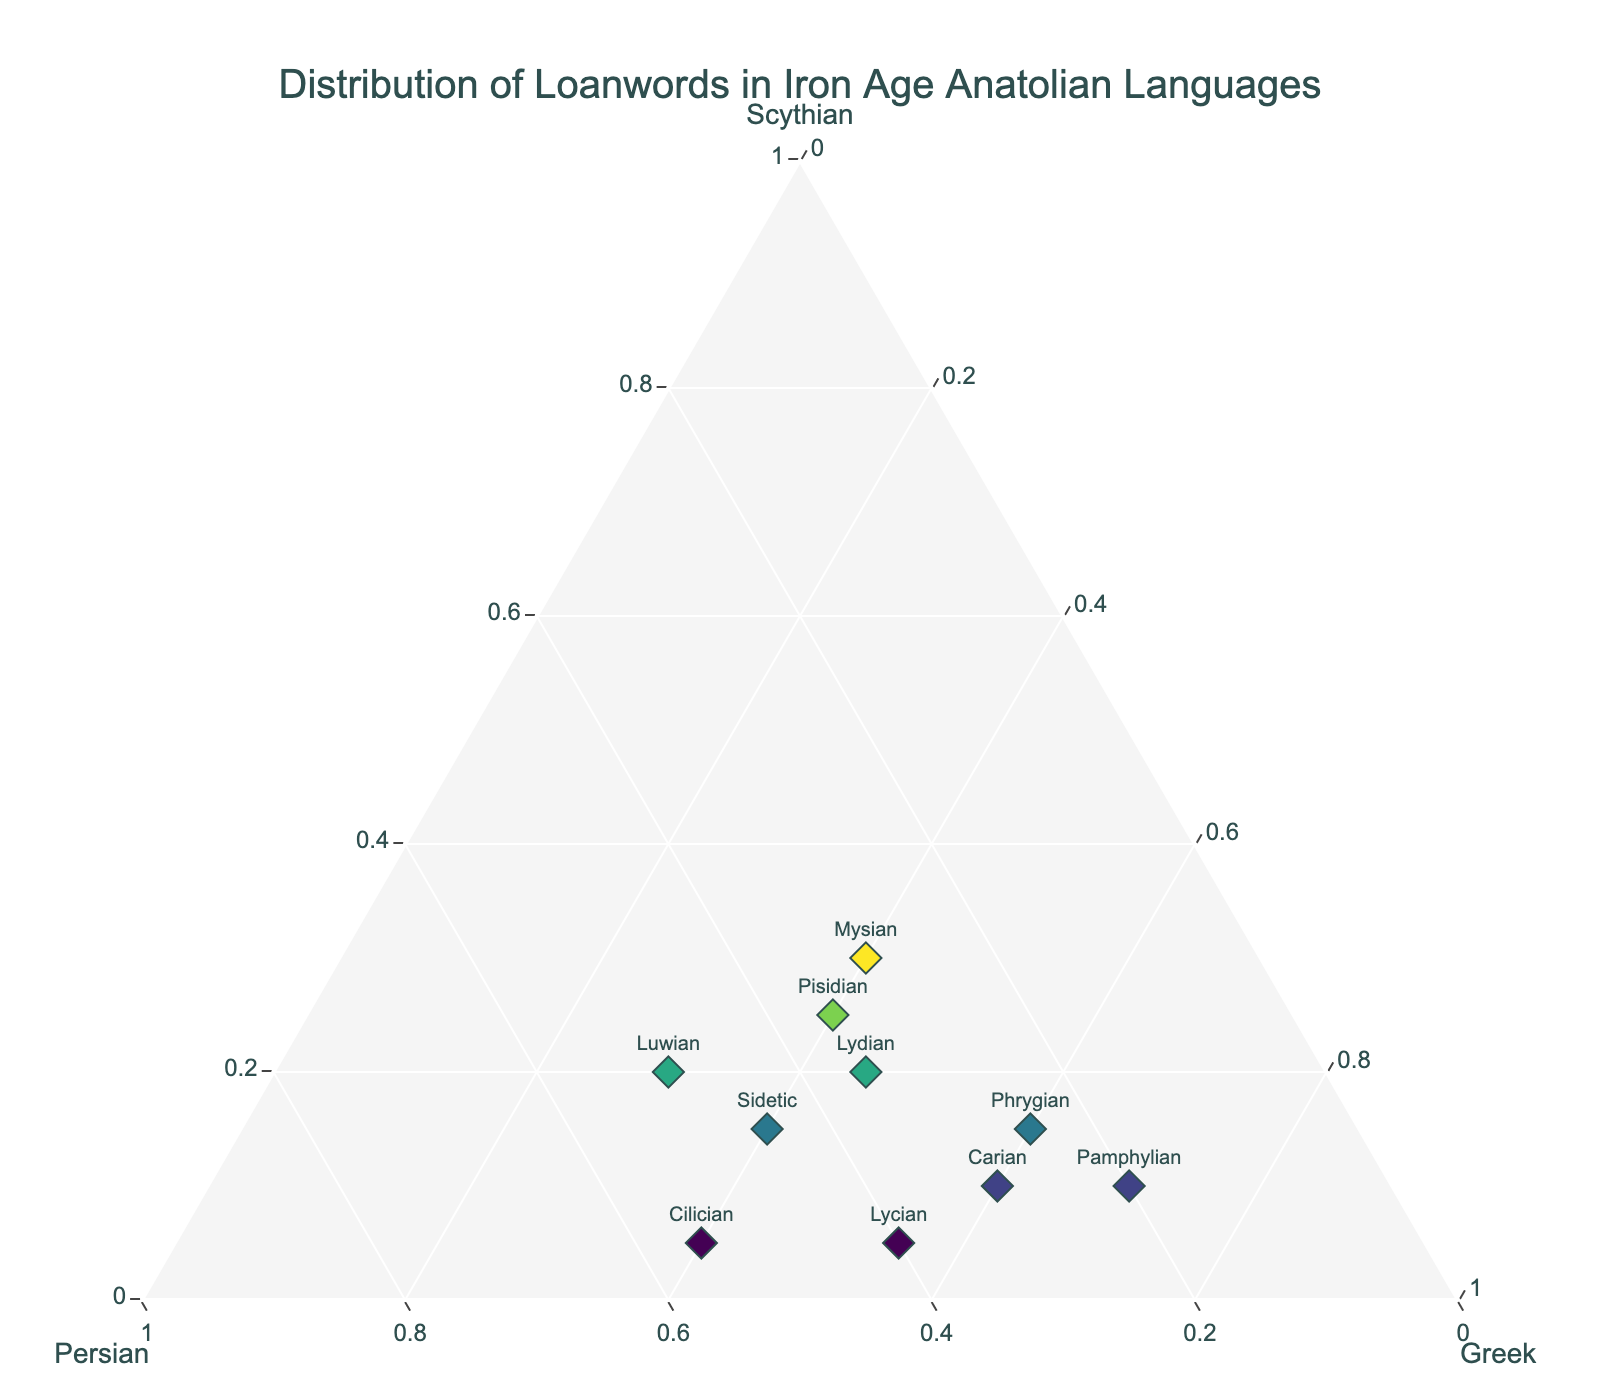What's the title of the figure? The title is often located at the top of the plot in larger font and more prominent compared to other texts.
Answer: Distribution of Loanwords in Iron Age Anatolian Languages How many languages are displayed in the plot? Count the unique markers or text labels representing each language on the plot.
Answer: 10 Which language has the highest proportion of Greek loanwords? Locate the language near the Greek (c-axis) corner of the ternary plot.
Answer: Pamphylian Which language has equal proportions of Persian and Scythian loanwords? Find the language whose markers are equidistant between the Persian (b-axis) and Scythian (a-axis) corners.
Answer: Mysian What is the average proportion of Persian loanwords across all languages? Sum the Persian values and then divide by the number of languages: (0.25 + 0.35 + 0.30 + 0.40 + 0.35 + 0.45 + 0.20 + 0.30 + 0.50 + 0.55) / 10 = 0.365.
Answer: 0.365 Which language has the closest proportions of all three loanwords? Find the language whose marker is closest to the center of the ternary plot, indicating similar proportions of Scythian, Persian, and Greek loanwords.
Answer: Mysian What is the combined proportion of Greek and Scythian loanwords in Pisidian? Add the Greek and Scythian values for Pisidian: 0.40 + 0.25 = 0.65.
Answer: 0.65 Which language features the highest proportion of Persian loanwords? Locate the language closest to the Persian (b-axis) corner of the ternary plot.
Answer: Cilician What’s the difference in Greek loanword proportions between Phrygian and Carian? Subtract the Greek loanword percentage of Carian from Phrygian: 0.60 - 0.60 = 0.
Answer: 0 Which language has the smallest proportion of Scythian loanwords? Locate the language closest to the Greek (c-axis) and Persian (b-axis) sides, furthest from the Scythian (a-axis) side.
Answer: Lycian 